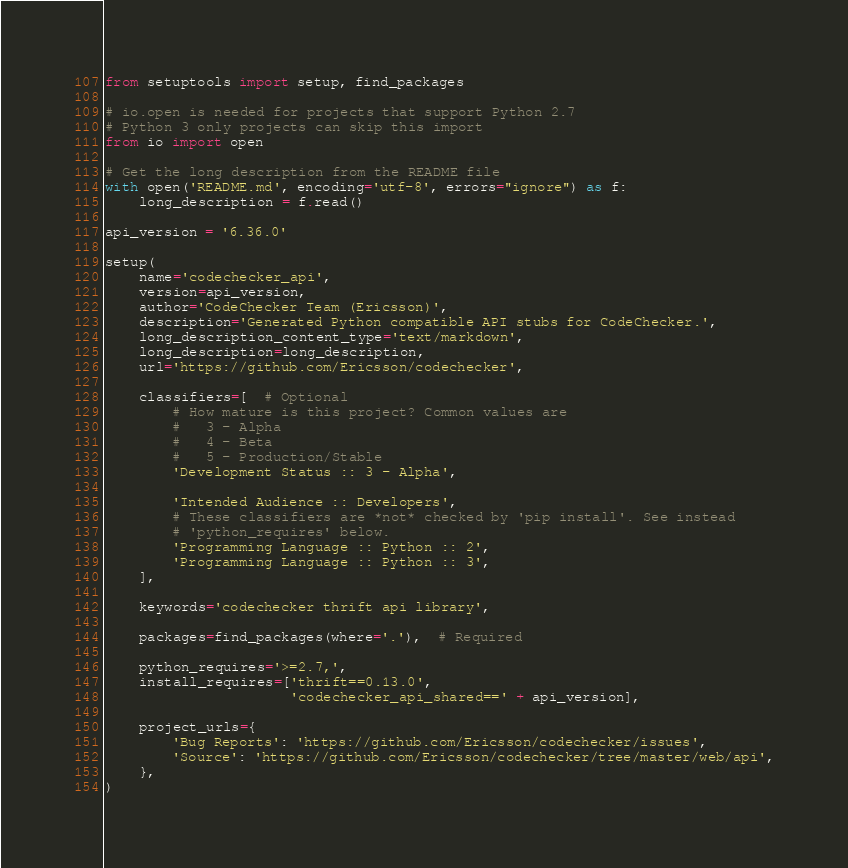Convert code to text. <code><loc_0><loc_0><loc_500><loc_500><_Python_>from setuptools import setup, find_packages

# io.open is needed for projects that support Python 2.7
# Python 3 only projects can skip this import
from io import open

# Get the long description from the README file
with open('README.md', encoding='utf-8', errors="ignore") as f:
    long_description = f.read()

api_version = '6.36.0'

setup(
    name='codechecker_api',
    version=api_version,
    author='CodeChecker Team (Ericsson)',
    description='Generated Python compatible API stubs for CodeChecker.',
    long_description_content_type='text/markdown',
    long_description=long_description,
    url='https://github.com/Ericsson/codechecker',

    classifiers=[  # Optional
        # How mature is this project? Common values are
        #   3 - Alpha
        #   4 - Beta
        #   5 - Production/Stable
        'Development Status :: 3 - Alpha',

        'Intended Audience :: Developers',
        # These classifiers are *not* checked by 'pip install'. See instead
        # 'python_requires' below.
        'Programming Language :: Python :: 2',
        'Programming Language :: Python :: 3',
    ],

    keywords='codechecker thrift api library',

    packages=find_packages(where='.'),  # Required

    python_requires='>=2.7,',
    install_requires=['thrift==0.13.0',
                      'codechecker_api_shared==' + api_version],

    project_urls={
        'Bug Reports': 'https://github.com/Ericsson/codechecker/issues',
        'Source': 'https://github.com/Ericsson/codechecker/tree/master/web/api',
    },
)
</code> 